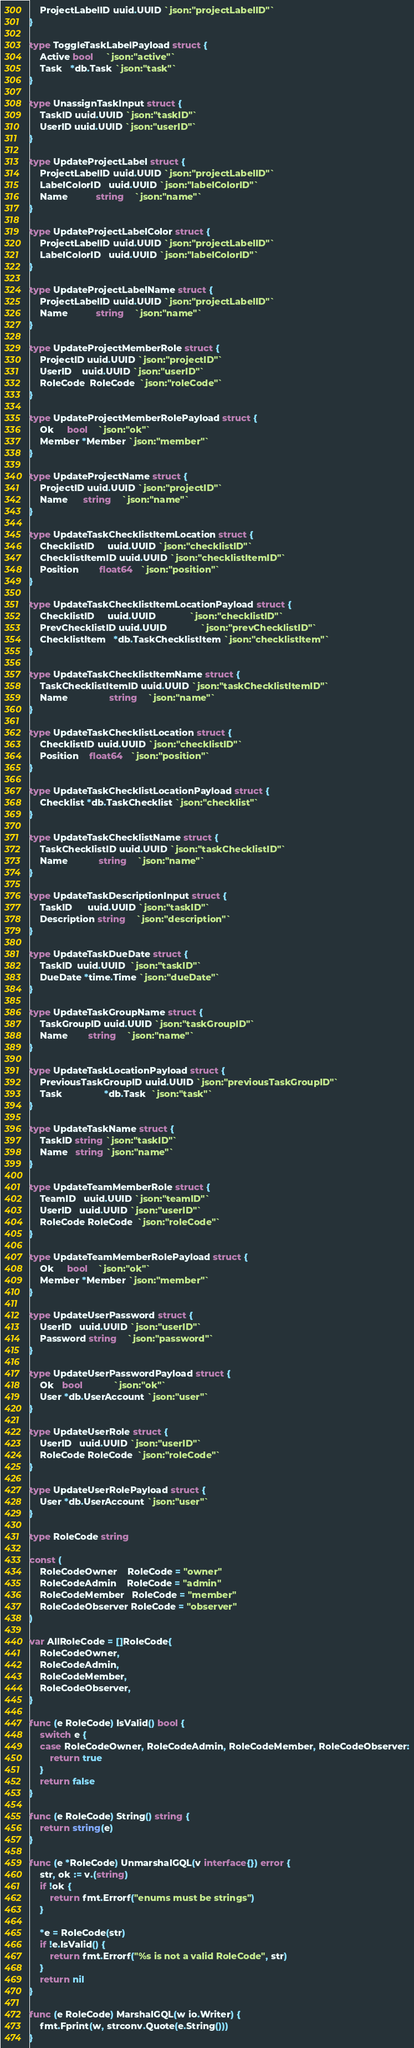<code> <loc_0><loc_0><loc_500><loc_500><_Go_>	ProjectLabelID uuid.UUID `json:"projectLabelID"`
}

type ToggleTaskLabelPayload struct {
	Active bool     `json:"active"`
	Task   *db.Task `json:"task"`
}

type UnassignTaskInput struct {
	TaskID uuid.UUID `json:"taskID"`
	UserID uuid.UUID `json:"userID"`
}

type UpdateProjectLabel struct {
	ProjectLabelID uuid.UUID `json:"projectLabelID"`
	LabelColorID   uuid.UUID `json:"labelColorID"`
	Name           string    `json:"name"`
}

type UpdateProjectLabelColor struct {
	ProjectLabelID uuid.UUID `json:"projectLabelID"`
	LabelColorID   uuid.UUID `json:"labelColorID"`
}

type UpdateProjectLabelName struct {
	ProjectLabelID uuid.UUID `json:"projectLabelID"`
	Name           string    `json:"name"`
}

type UpdateProjectMemberRole struct {
	ProjectID uuid.UUID `json:"projectID"`
	UserID    uuid.UUID `json:"userID"`
	RoleCode  RoleCode  `json:"roleCode"`
}

type UpdateProjectMemberRolePayload struct {
	Ok     bool    `json:"ok"`
	Member *Member `json:"member"`
}

type UpdateProjectName struct {
	ProjectID uuid.UUID `json:"projectID"`
	Name      string    `json:"name"`
}

type UpdateTaskChecklistItemLocation struct {
	ChecklistID     uuid.UUID `json:"checklistID"`
	ChecklistItemID uuid.UUID `json:"checklistItemID"`
	Position        float64   `json:"position"`
}

type UpdateTaskChecklistItemLocationPayload struct {
	ChecklistID     uuid.UUID             `json:"checklistID"`
	PrevChecklistID uuid.UUID             `json:"prevChecklistID"`
	ChecklistItem   *db.TaskChecklistItem `json:"checklistItem"`
}

type UpdateTaskChecklistItemName struct {
	TaskChecklistItemID uuid.UUID `json:"taskChecklistItemID"`
	Name                string    `json:"name"`
}

type UpdateTaskChecklistLocation struct {
	ChecklistID uuid.UUID `json:"checklistID"`
	Position    float64   `json:"position"`
}

type UpdateTaskChecklistLocationPayload struct {
	Checklist *db.TaskChecklist `json:"checklist"`
}

type UpdateTaskChecklistName struct {
	TaskChecklistID uuid.UUID `json:"taskChecklistID"`
	Name            string    `json:"name"`
}

type UpdateTaskDescriptionInput struct {
	TaskID      uuid.UUID `json:"taskID"`
	Description string    `json:"description"`
}

type UpdateTaskDueDate struct {
	TaskID  uuid.UUID  `json:"taskID"`
	DueDate *time.Time `json:"dueDate"`
}

type UpdateTaskGroupName struct {
	TaskGroupID uuid.UUID `json:"taskGroupID"`
	Name        string    `json:"name"`
}

type UpdateTaskLocationPayload struct {
	PreviousTaskGroupID uuid.UUID `json:"previousTaskGroupID"`
	Task                *db.Task  `json:"task"`
}

type UpdateTaskName struct {
	TaskID string `json:"taskID"`
	Name   string `json:"name"`
}

type UpdateTeamMemberRole struct {
	TeamID   uuid.UUID `json:"teamID"`
	UserID   uuid.UUID `json:"userID"`
	RoleCode RoleCode  `json:"roleCode"`
}

type UpdateTeamMemberRolePayload struct {
	Ok     bool    `json:"ok"`
	Member *Member `json:"member"`
}

type UpdateUserPassword struct {
	UserID   uuid.UUID `json:"userID"`
	Password string    `json:"password"`
}

type UpdateUserPasswordPayload struct {
	Ok   bool            `json:"ok"`
	User *db.UserAccount `json:"user"`
}

type UpdateUserRole struct {
	UserID   uuid.UUID `json:"userID"`
	RoleCode RoleCode  `json:"roleCode"`
}

type UpdateUserRolePayload struct {
	User *db.UserAccount `json:"user"`
}

type RoleCode string

const (
	RoleCodeOwner    RoleCode = "owner"
	RoleCodeAdmin    RoleCode = "admin"
	RoleCodeMember   RoleCode = "member"
	RoleCodeObserver RoleCode = "observer"
)

var AllRoleCode = []RoleCode{
	RoleCodeOwner,
	RoleCodeAdmin,
	RoleCodeMember,
	RoleCodeObserver,
}

func (e RoleCode) IsValid() bool {
	switch e {
	case RoleCodeOwner, RoleCodeAdmin, RoleCodeMember, RoleCodeObserver:
		return true
	}
	return false
}

func (e RoleCode) String() string {
	return string(e)
}

func (e *RoleCode) UnmarshalGQL(v interface{}) error {
	str, ok := v.(string)
	if !ok {
		return fmt.Errorf("enums must be strings")
	}

	*e = RoleCode(str)
	if !e.IsValid() {
		return fmt.Errorf("%s is not a valid RoleCode", str)
	}
	return nil
}

func (e RoleCode) MarshalGQL(w io.Writer) {
	fmt.Fprint(w, strconv.Quote(e.String()))
}
</code> 